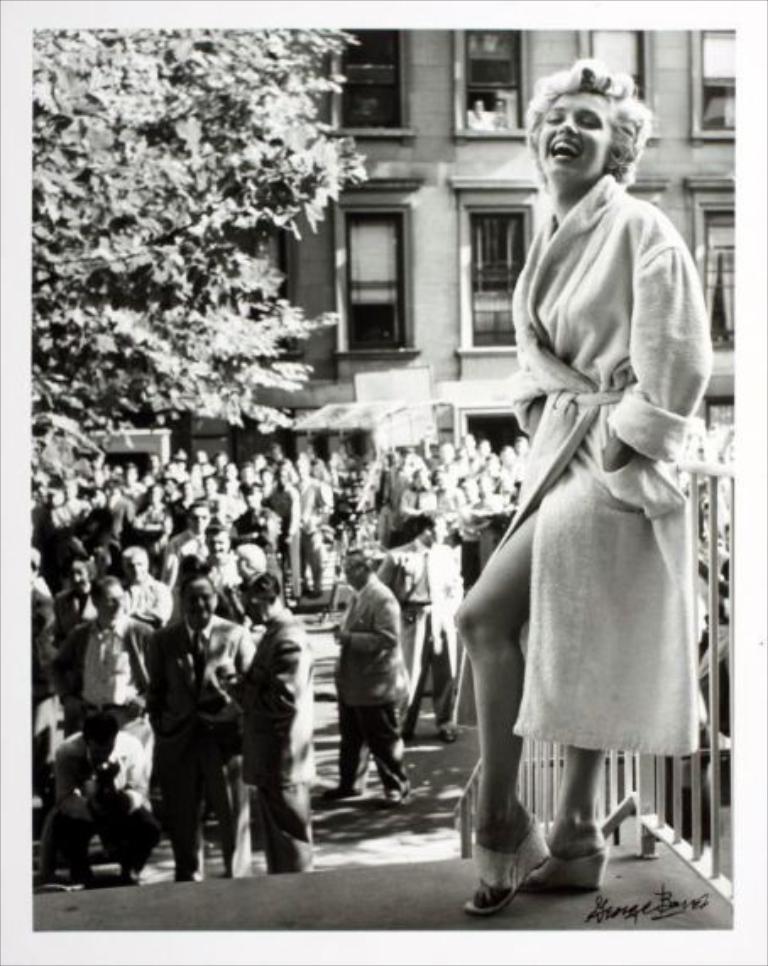How would you summarize this image in a sentence or two? This image is a black and white image. This image is taken outdoors. At the bottom of the image there is a floor. On the right side of the image there is a railing and a woman is standing on the floor. She is with a smiling face. In the background there is a building with walls and windows and there is a tree. In the middle of the image many people are standing on the road and a few are walking. On the left side of the image a man is in a squatting position and he is clicking pictures with a camera. 